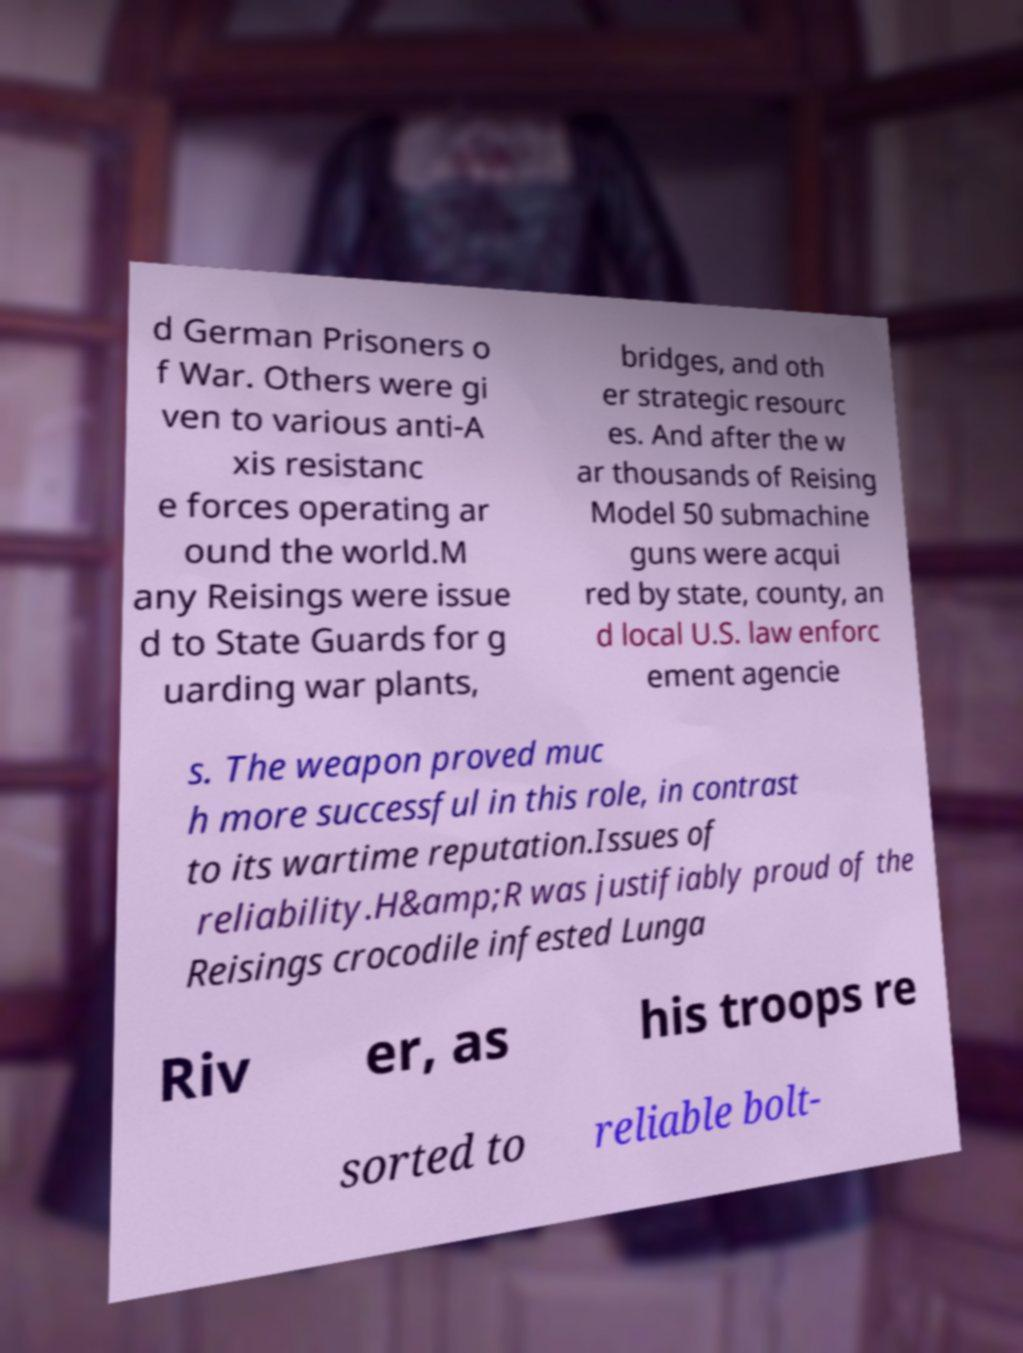For documentation purposes, I need the text within this image transcribed. Could you provide that? d German Prisoners o f War. Others were gi ven to various anti-A xis resistanc e forces operating ar ound the world.M any Reisings were issue d to State Guards for g uarding war plants, bridges, and oth er strategic resourc es. And after the w ar thousands of Reising Model 50 submachine guns were acqui red by state, county, an d local U.S. law enforc ement agencie s. The weapon proved muc h more successful in this role, in contrast to its wartime reputation.Issues of reliability.H&amp;R was justifiably proud of the Reisings crocodile infested Lunga Riv er, as his troops re sorted to reliable bolt- 